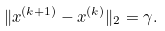Convert formula to latex. <formula><loc_0><loc_0><loc_500><loc_500>\| x ^ { ( k + 1 ) } - x ^ { ( k ) } \| _ { 2 } = \gamma .</formula> 